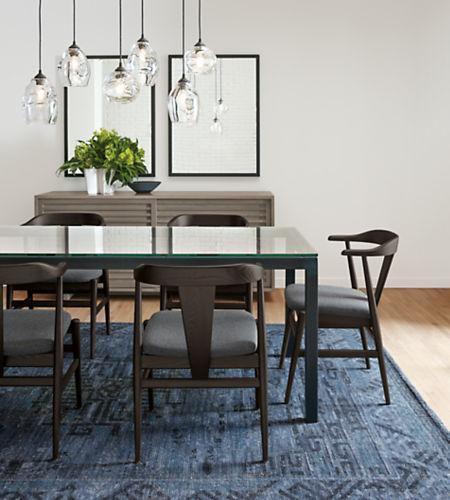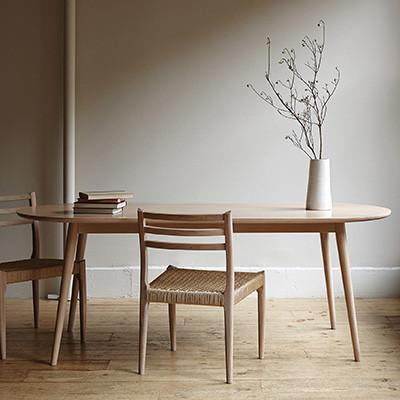The first image is the image on the left, the second image is the image on the right. Examine the images to the left and right. Is the description "there are exactly two chairs in the image on the right" accurate? Answer yes or no. Yes. The first image is the image on the left, the second image is the image on the right. Evaluate the accuracy of this statement regarding the images: "At least one image shows a rectangular dining table with chairs on each side and each end.". Is it true? Answer yes or no. No. 